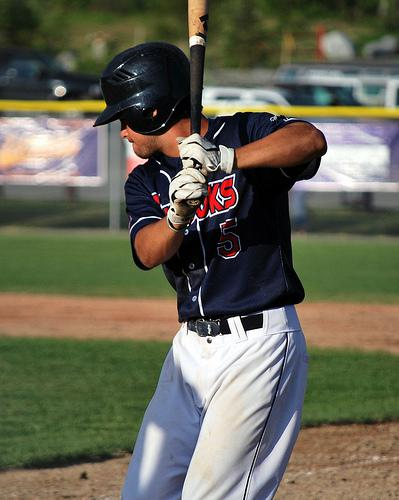Question: how many gloves is the man wearing?
Choices:
A. Two.
B. Four.
C. Six.
D. Three.
Answer with the letter. Answer: A Question: what is on the man's head?
Choices:
A. Hat.
B. Nothing.
C. A helmet.
D. Sunglasses.
Answer with the letter. Answer: C Question: who is wearing a helmet?
Choices:
A. Motorcyclist.
B. A baseball player.
C. Skateboarder.
D. Football player.
Answer with the letter. Answer: B 